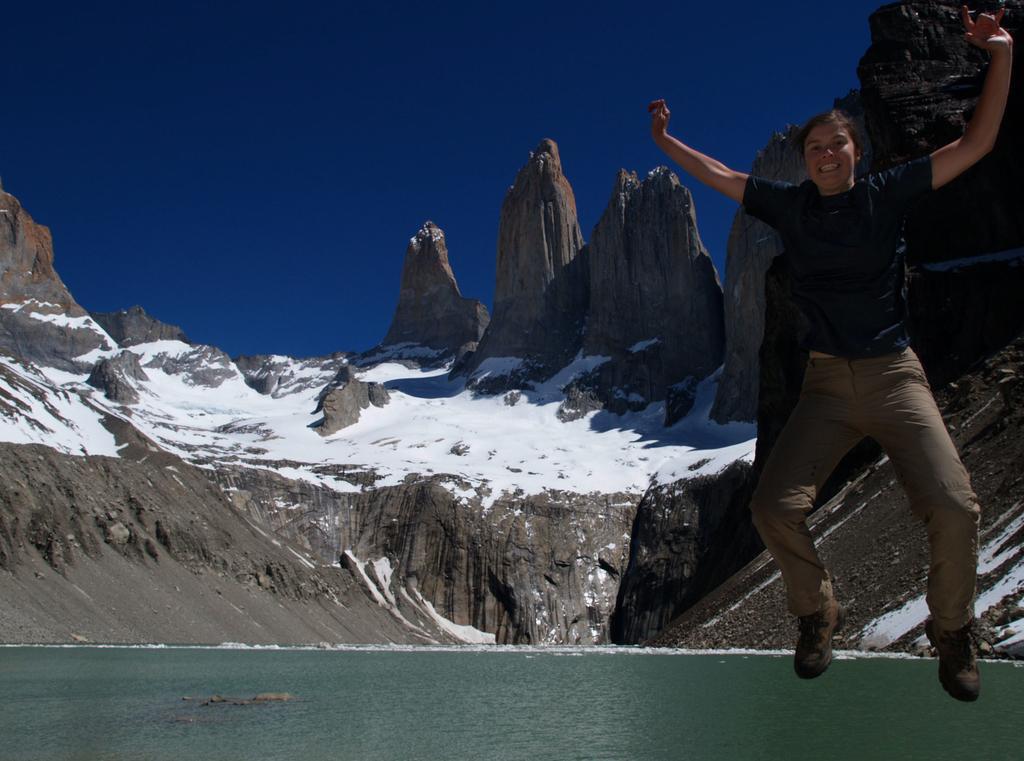Please provide a concise description of this image. In this image I can see the person in the air. In the background I can see the water, mountains and I can also see the snow and the sky is in blue color. 